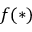Convert formula to latex. <formula><loc_0><loc_0><loc_500><loc_500>f ( * )</formula> 